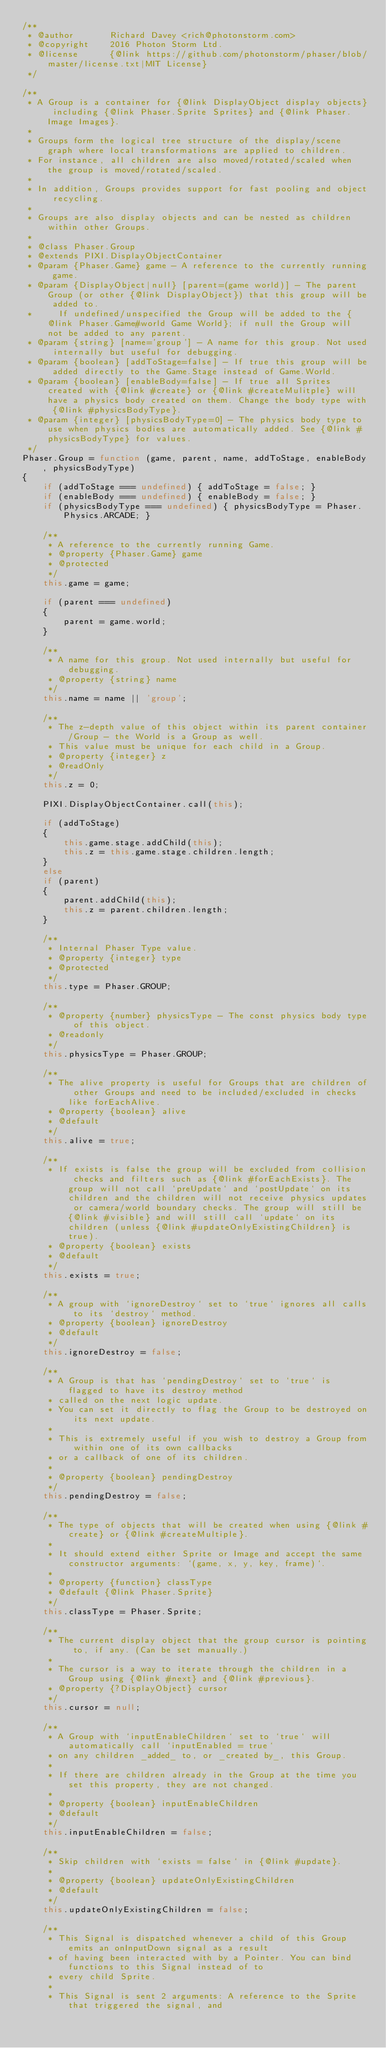<code> <loc_0><loc_0><loc_500><loc_500><_JavaScript_>/**
 * @author       Richard Davey <rich@photonstorm.com>
 * @copyright    2016 Photon Storm Ltd.
 * @license      {@link https://github.com/photonstorm/phaser/blob/master/license.txt|MIT License}
 */

/**
 * A Group is a container for {@link DisplayObject display objects} including {@link Phaser.Sprite Sprites} and {@link Phaser.Image Images}.
 *
 * Groups form the logical tree structure of the display/scene graph where local transformations are applied to children.
 * For instance, all children are also moved/rotated/scaled when the group is moved/rotated/scaled.
 *
 * In addition, Groups provides support for fast pooling and object recycling.
 *
 * Groups are also display objects and can be nested as children within other Groups.
 *
 * @class Phaser.Group
 * @extends PIXI.DisplayObjectContainer
 * @param {Phaser.Game} game - A reference to the currently running game.
 * @param {DisplayObject|null} [parent=(game world)] - The parent Group (or other {@link DisplayObject}) that this group will be added to.
 *     If undefined/unspecified the Group will be added to the {@link Phaser.Game#world Game World}; if null the Group will not be added to any parent.
 * @param {string} [name='group'] - A name for this group. Not used internally but useful for debugging.
 * @param {boolean} [addToStage=false] - If true this group will be added directly to the Game.Stage instead of Game.World.
 * @param {boolean} [enableBody=false] - If true all Sprites created with {@link #create} or {@link #createMulitple} will have a physics body created on them. Change the body type with {@link #physicsBodyType}.
 * @param {integer} [physicsBodyType=0] - The physics body type to use when physics bodies are automatically added. See {@link #physicsBodyType} for values.
 */
Phaser.Group = function (game, parent, name, addToStage, enableBody, physicsBodyType)
{
    if (addToStage === undefined) { addToStage = false; }
    if (enableBody === undefined) { enableBody = false; }
    if (physicsBodyType === undefined) { physicsBodyType = Phaser.Physics.ARCADE; }

    /**
     * A reference to the currently running Game.
     * @property {Phaser.Game} game
     * @protected
     */
    this.game = game;

    if (parent === undefined)
    {
        parent = game.world;
    }

    /**
     * A name for this group. Not used internally but useful for debugging.
     * @property {string} name
     */
    this.name = name || 'group';

    /**
     * The z-depth value of this object within its parent container/Group - the World is a Group as well.
     * This value must be unique for each child in a Group.
     * @property {integer} z
     * @readOnly
     */
    this.z = 0;

    PIXI.DisplayObjectContainer.call(this);

    if (addToStage)
    {
        this.game.stage.addChild(this);
        this.z = this.game.stage.children.length;
    }
    else
    if (parent)
    {
        parent.addChild(this);
        this.z = parent.children.length;
    }

    /**
     * Internal Phaser Type value.
     * @property {integer} type
     * @protected
     */
    this.type = Phaser.GROUP;

    /**
     * @property {number} physicsType - The const physics body type of this object.
     * @readonly
     */
    this.physicsType = Phaser.GROUP;

    /**
     * The alive property is useful for Groups that are children of other Groups and need to be included/excluded in checks like forEachAlive.
     * @property {boolean} alive
     * @default
     */
    this.alive = true;

    /**
     * If exists is false the group will be excluded from collision checks and filters such as {@link #forEachExists}. The group will not call `preUpdate` and `postUpdate` on its children and the children will not receive physics updates or camera/world boundary checks. The group will still be {@link #visible} and will still call `update` on its children (unless {@link #updateOnlyExistingChildren} is true).
     * @property {boolean} exists
     * @default
     */
    this.exists = true;

    /**
     * A group with `ignoreDestroy` set to `true` ignores all calls to its `destroy` method.
     * @property {boolean} ignoreDestroy
     * @default
     */
    this.ignoreDestroy = false;

    /**
     * A Group is that has `pendingDestroy` set to `true` is flagged to have its destroy method
     * called on the next logic update.
     * You can set it directly to flag the Group to be destroyed on its next update.
     *
     * This is extremely useful if you wish to destroy a Group from within one of its own callbacks
     * or a callback of one of its children.
     *
     * @property {boolean} pendingDestroy
     */
    this.pendingDestroy = false;

    /**
     * The type of objects that will be created when using {@link #create} or {@link #createMultiple}.
     *
     * It should extend either Sprite or Image and accept the same constructor arguments: `(game, x, y, key, frame)`.
     *
     * @property {function} classType
     * @default {@link Phaser.Sprite}
     */
    this.classType = Phaser.Sprite;

    /**
     * The current display object that the group cursor is pointing to, if any. (Can be set manually.)
     *
     * The cursor is a way to iterate through the children in a Group using {@link #next} and {@link #previous}.
     * @property {?DisplayObject} cursor
     */
    this.cursor = null;

    /**
     * A Group with `inputEnableChildren` set to `true` will automatically call `inputEnabled = true`
     * on any children _added_ to, or _created by_, this Group.
     *
     * If there are children already in the Group at the time you set this property, they are not changed.
     *
     * @property {boolean} inputEnableChildren
     * @default
     */
    this.inputEnableChildren = false;

    /**
     * Skip children with `exists = false` in {@link #update}.
     *
     * @property {boolean} updateOnlyExistingChildren
     * @default
     */
    this.updateOnlyExistingChildren = false;

    /**
     * This Signal is dispatched whenever a child of this Group emits an onInputDown signal as a result
     * of having been interacted with by a Pointer. You can bind functions to this Signal instead of to
     * every child Sprite.
     *
     * This Signal is sent 2 arguments: A reference to the Sprite that triggered the signal, and</code> 